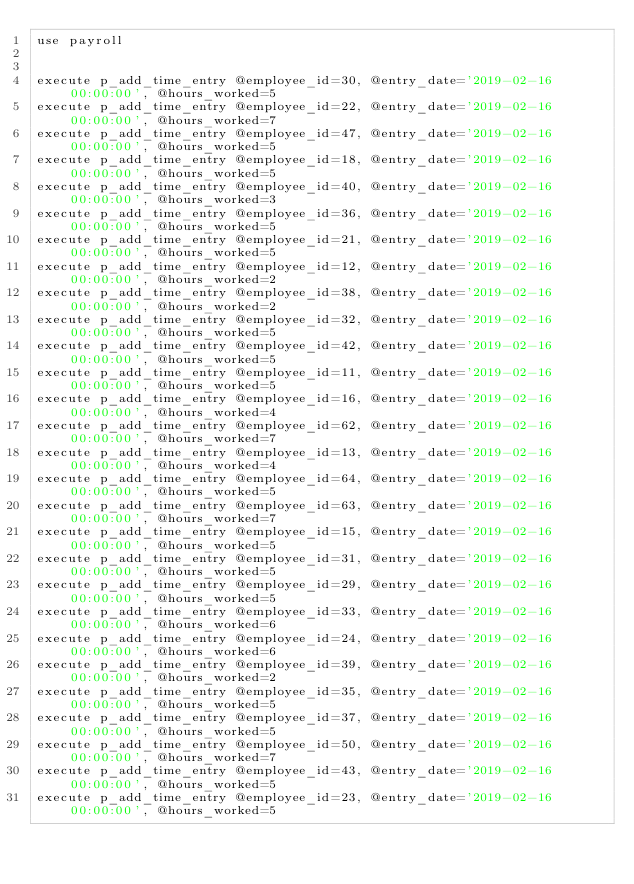<code> <loc_0><loc_0><loc_500><loc_500><_SQL_>use payroll


execute p_add_time_entry @employee_id=30, @entry_date='2019-02-16 00:00:00', @hours_worked=5
execute p_add_time_entry @employee_id=22, @entry_date='2019-02-16 00:00:00', @hours_worked=7
execute p_add_time_entry @employee_id=47, @entry_date='2019-02-16 00:00:00', @hours_worked=5
execute p_add_time_entry @employee_id=18, @entry_date='2019-02-16 00:00:00', @hours_worked=5
execute p_add_time_entry @employee_id=40, @entry_date='2019-02-16 00:00:00', @hours_worked=3
execute p_add_time_entry @employee_id=36, @entry_date='2019-02-16 00:00:00', @hours_worked=5
execute p_add_time_entry @employee_id=21, @entry_date='2019-02-16 00:00:00', @hours_worked=5
execute p_add_time_entry @employee_id=12, @entry_date='2019-02-16 00:00:00', @hours_worked=2
execute p_add_time_entry @employee_id=38, @entry_date='2019-02-16 00:00:00', @hours_worked=2
execute p_add_time_entry @employee_id=32, @entry_date='2019-02-16 00:00:00', @hours_worked=5
execute p_add_time_entry @employee_id=42, @entry_date='2019-02-16 00:00:00', @hours_worked=5
execute p_add_time_entry @employee_id=11, @entry_date='2019-02-16 00:00:00', @hours_worked=5
execute p_add_time_entry @employee_id=16, @entry_date='2019-02-16 00:00:00', @hours_worked=4
execute p_add_time_entry @employee_id=62, @entry_date='2019-02-16 00:00:00', @hours_worked=7
execute p_add_time_entry @employee_id=13, @entry_date='2019-02-16 00:00:00', @hours_worked=4
execute p_add_time_entry @employee_id=64, @entry_date='2019-02-16 00:00:00', @hours_worked=5
execute p_add_time_entry @employee_id=63, @entry_date='2019-02-16 00:00:00', @hours_worked=7
execute p_add_time_entry @employee_id=15, @entry_date='2019-02-16 00:00:00', @hours_worked=5
execute p_add_time_entry @employee_id=31, @entry_date='2019-02-16 00:00:00', @hours_worked=5
execute p_add_time_entry @employee_id=29, @entry_date='2019-02-16 00:00:00', @hours_worked=5
execute p_add_time_entry @employee_id=33, @entry_date='2019-02-16 00:00:00', @hours_worked=6
execute p_add_time_entry @employee_id=24, @entry_date='2019-02-16 00:00:00', @hours_worked=6
execute p_add_time_entry @employee_id=39, @entry_date='2019-02-16 00:00:00', @hours_worked=2
execute p_add_time_entry @employee_id=35, @entry_date='2019-02-16 00:00:00', @hours_worked=5
execute p_add_time_entry @employee_id=37, @entry_date='2019-02-16 00:00:00', @hours_worked=5
execute p_add_time_entry @employee_id=50, @entry_date='2019-02-16 00:00:00', @hours_worked=7
execute p_add_time_entry @employee_id=43, @entry_date='2019-02-16 00:00:00', @hours_worked=5
execute p_add_time_entry @employee_id=23, @entry_date='2019-02-16 00:00:00', @hours_worked=5

</code> 